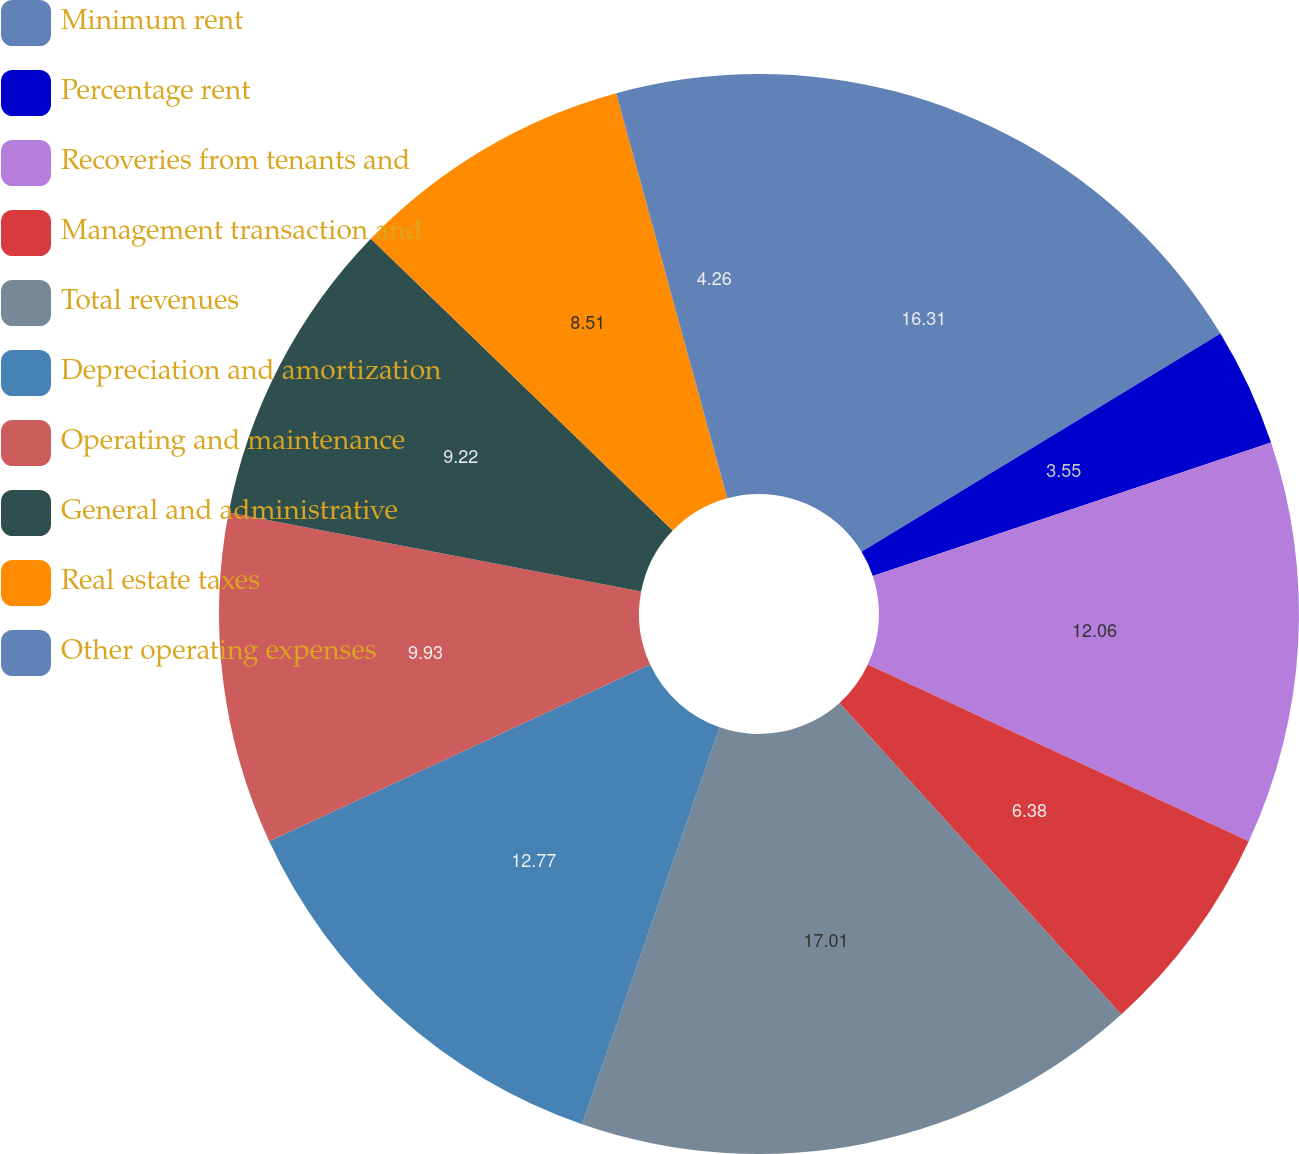Convert chart to OTSL. <chart><loc_0><loc_0><loc_500><loc_500><pie_chart><fcel>Minimum rent<fcel>Percentage rent<fcel>Recoveries from tenants and<fcel>Management transaction and<fcel>Total revenues<fcel>Depreciation and amortization<fcel>Operating and maintenance<fcel>General and administrative<fcel>Real estate taxes<fcel>Other operating expenses<nl><fcel>16.31%<fcel>3.55%<fcel>12.06%<fcel>6.38%<fcel>17.02%<fcel>12.77%<fcel>9.93%<fcel>9.22%<fcel>8.51%<fcel>4.26%<nl></chart> 